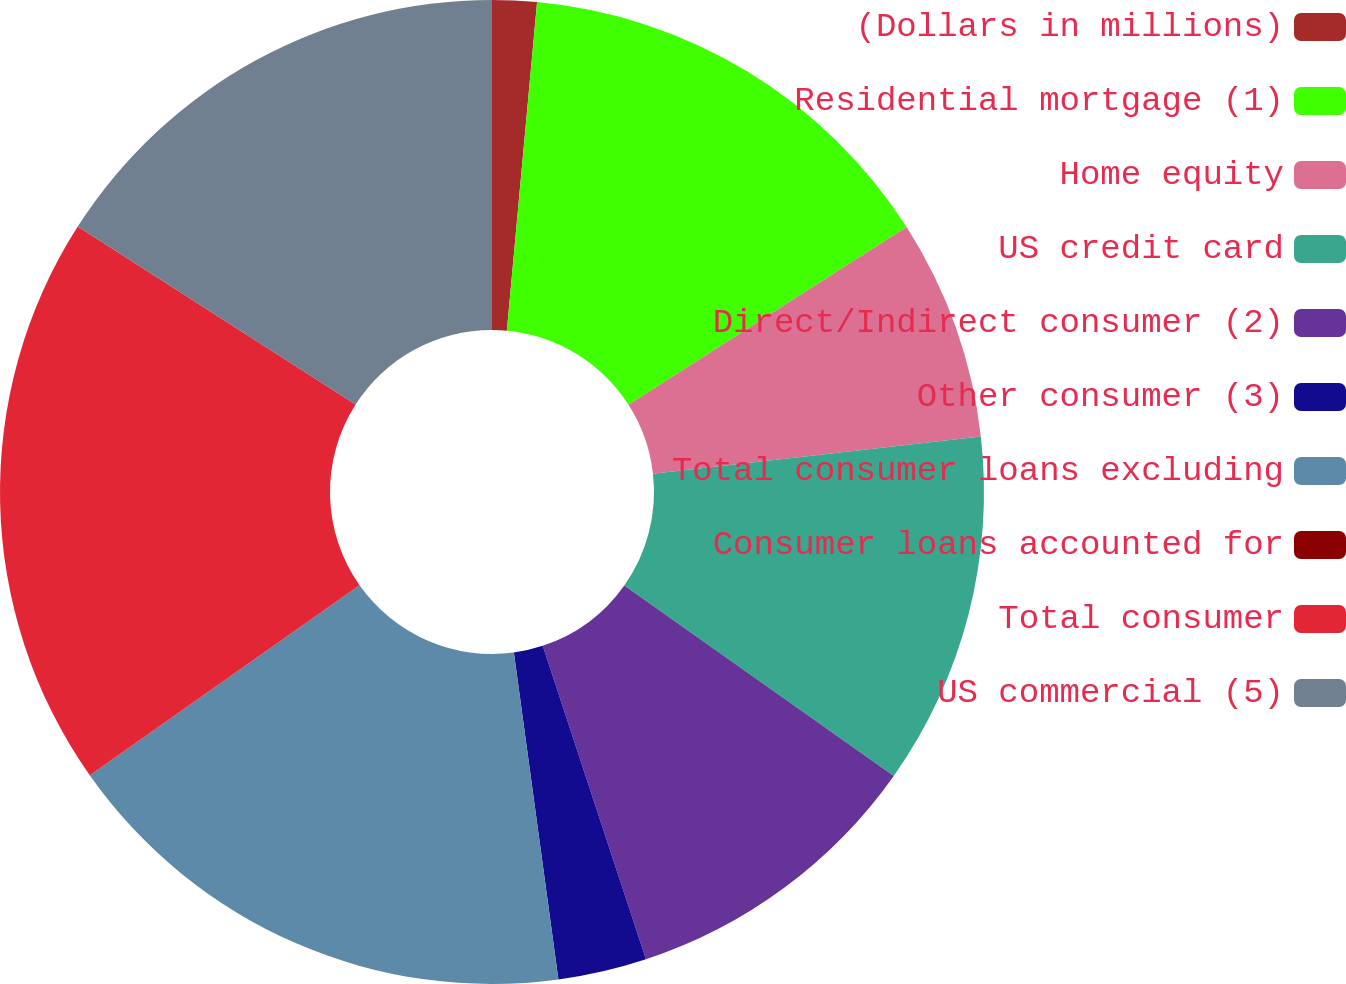<chart> <loc_0><loc_0><loc_500><loc_500><pie_chart><fcel>(Dollars in millions)<fcel>Residential mortgage (1)<fcel>Home equity<fcel>US credit card<fcel>Direct/Indirect consumer (2)<fcel>Other consumer (3)<fcel>Total consumer loans excluding<fcel>Consumer loans accounted for<fcel>Total consumer<fcel>US commercial (5)<nl><fcel>1.46%<fcel>14.49%<fcel>7.25%<fcel>11.59%<fcel>10.14%<fcel>2.91%<fcel>17.38%<fcel>0.01%<fcel>18.83%<fcel>15.93%<nl></chart> 